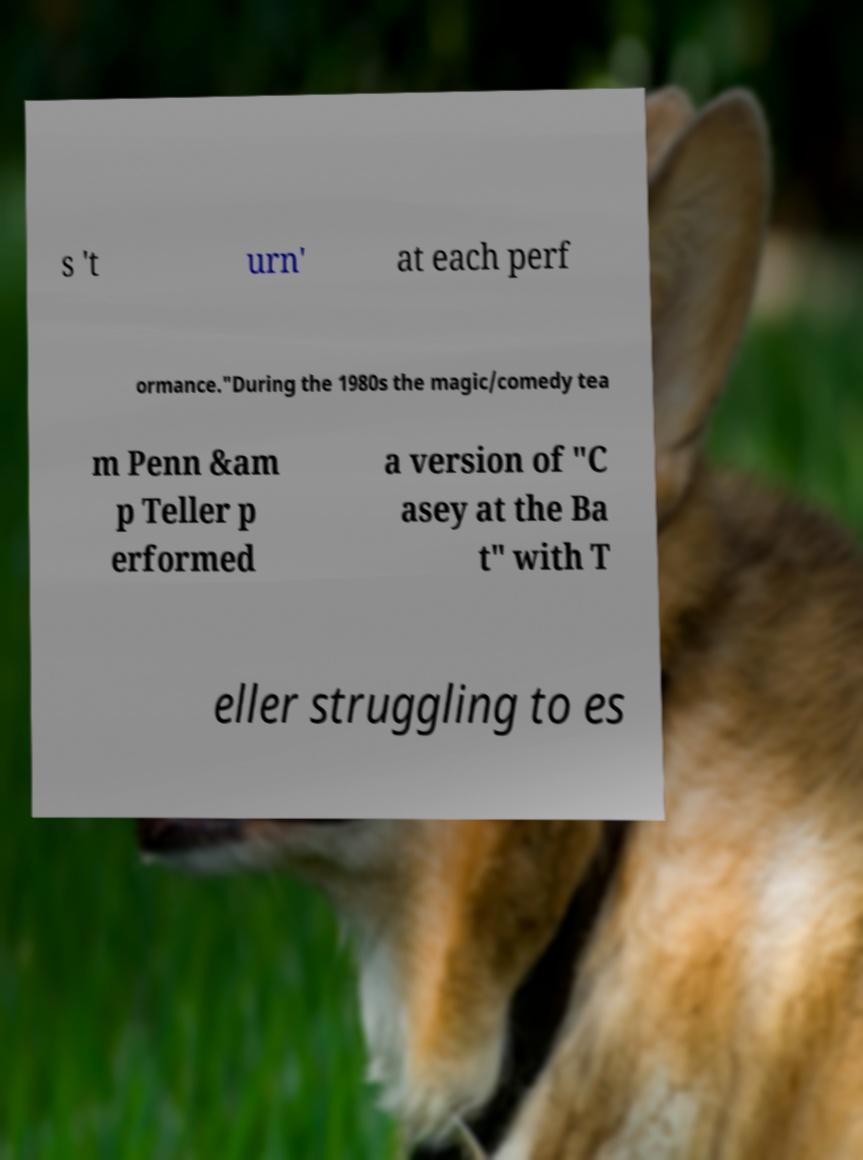What messages or text are displayed in this image? I need them in a readable, typed format. s 't urn' at each perf ormance."During the 1980s the magic/comedy tea m Penn &am p Teller p erformed a version of "C asey at the Ba t" with T eller struggling to es 